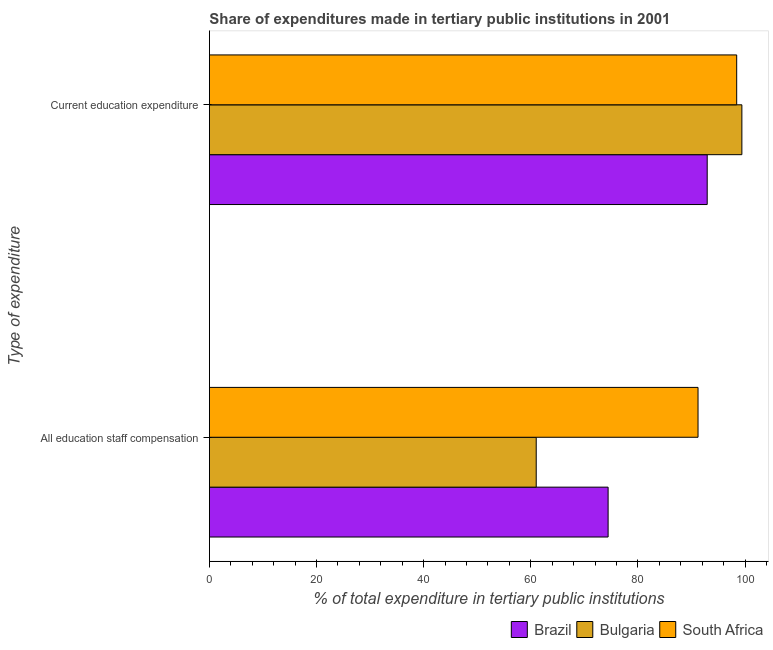How many different coloured bars are there?
Your answer should be compact. 3. Are the number of bars per tick equal to the number of legend labels?
Your answer should be compact. Yes. What is the label of the 1st group of bars from the top?
Ensure brevity in your answer.  Current education expenditure. What is the expenditure in staff compensation in South Africa?
Make the answer very short. 91.23. Across all countries, what is the maximum expenditure in staff compensation?
Your answer should be very brief. 91.23. Across all countries, what is the minimum expenditure in education?
Ensure brevity in your answer.  92.94. In which country was the expenditure in staff compensation maximum?
Give a very brief answer. South Africa. What is the total expenditure in education in the graph?
Your response must be concise. 290.8. What is the difference between the expenditure in staff compensation in South Africa and that in Bulgaria?
Give a very brief answer. 30.21. What is the difference between the expenditure in education in Bulgaria and the expenditure in staff compensation in South Africa?
Your answer should be compact. 8.18. What is the average expenditure in education per country?
Keep it short and to the point. 96.93. What is the difference between the expenditure in staff compensation and expenditure in education in Bulgaria?
Give a very brief answer. -38.4. In how many countries, is the expenditure in staff compensation greater than 16 %?
Give a very brief answer. 3. What is the ratio of the expenditure in education in Brazil to that in South Africa?
Your answer should be very brief. 0.94. Is the expenditure in education in Brazil less than that in South Africa?
Offer a very short reply. Yes. In how many countries, is the expenditure in education greater than the average expenditure in education taken over all countries?
Offer a terse response. 2. What does the 1st bar from the top in Current education expenditure represents?
Your response must be concise. South Africa. What does the 3rd bar from the bottom in All education staff compensation represents?
Offer a very short reply. South Africa. How many bars are there?
Ensure brevity in your answer.  6. Are all the bars in the graph horizontal?
Your answer should be compact. Yes. How many countries are there in the graph?
Provide a succinct answer. 3. Are the values on the major ticks of X-axis written in scientific E-notation?
Keep it short and to the point. No. Does the graph contain any zero values?
Offer a very short reply. No. What is the title of the graph?
Provide a succinct answer. Share of expenditures made in tertiary public institutions in 2001. Does "Montenegro" appear as one of the legend labels in the graph?
Provide a succinct answer. No. What is the label or title of the X-axis?
Ensure brevity in your answer.  % of total expenditure in tertiary public institutions. What is the label or title of the Y-axis?
Give a very brief answer. Type of expenditure. What is the % of total expenditure in tertiary public institutions of Brazil in All education staff compensation?
Give a very brief answer. 74.44. What is the % of total expenditure in tertiary public institutions in Bulgaria in All education staff compensation?
Ensure brevity in your answer.  61.02. What is the % of total expenditure in tertiary public institutions in South Africa in All education staff compensation?
Give a very brief answer. 91.23. What is the % of total expenditure in tertiary public institutions of Brazil in Current education expenditure?
Provide a short and direct response. 92.94. What is the % of total expenditure in tertiary public institutions in Bulgaria in Current education expenditure?
Make the answer very short. 99.41. What is the % of total expenditure in tertiary public institutions of South Africa in Current education expenditure?
Give a very brief answer. 98.45. Across all Type of expenditure, what is the maximum % of total expenditure in tertiary public institutions in Brazil?
Ensure brevity in your answer.  92.94. Across all Type of expenditure, what is the maximum % of total expenditure in tertiary public institutions in Bulgaria?
Provide a short and direct response. 99.41. Across all Type of expenditure, what is the maximum % of total expenditure in tertiary public institutions of South Africa?
Your response must be concise. 98.45. Across all Type of expenditure, what is the minimum % of total expenditure in tertiary public institutions of Brazil?
Provide a short and direct response. 74.44. Across all Type of expenditure, what is the minimum % of total expenditure in tertiary public institutions of Bulgaria?
Your answer should be very brief. 61.02. Across all Type of expenditure, what is the minimum % of total expenditure in tertiary public institutions in South Africa?
Provide a short and direct response. 91.23. What is the total % of total expenditure in tertiary public institutions in Brazil in the graph?
Keep it short and to the point. 167.38. What is the total % of total expenditure in tertiary public institutions in Bulgaria in the graph?
Provide a short and direct response. 160.43. What is the total % of total expenditure in tertiary public institutions of South Africa in the graph?
Ensure brevity in your answer.  189.68. What is the difference between the % of total expenditure in tertiary public institutions in Brazil in All education staff compensation and that in Current education expenditure?
Make the answer very short. -18.5. What is the difference between the % of total expenditure in tertiary public institutions of Bulgaria in All education staff compensation and that in Current education expenditure?
Provide a short and direct response. -38.4. What is the difference between the % of total expenditure in tertiary public institutions in South Africa in All education staff compensation and that in Current education expenditure?
Offer a terse response. -7.22. What is the difference between the % of total expenditure in tertiary public institutions of Brazil in All education staff compensation and the % of total expenditure in tertiary public institutions of Bulgaria in Current education expenditure?
Provide a short and direct response. -24.97. What is the difference between the % of total expenditure in tertiary public institutions of Brazil in All education staff compensation and the % of total expenditure in tertiary public institutions of South Africa in Current education expenditure?
Provide a short and direct response. -24.01. What is the difference between the % of total expenditure in tertiary public institutions of Bulgaria in All education staff compensation and the % of total expenditure in tertiary public institutions of South Africa in Current education expenditure?
Keep it short and to the point. -37.43. What is the average % of total expenditure in tertiary public institutions of Brazil per Type of expenditure?
Keep it short and to the point. 83.69. What is the average % of total expenditure in tertiary public institutions of Bulgaria per Type of expenditure?
Make the answer very short. 80.22. What is the average % of total expenditure in tertiary public institutions of South Africa per Type of expenditure?
Give a very brief answer. 94.84. What is the difference between the % of total expenditure in tertiary public institutions of Brazil and % of total expenditure in tertiary public institutions of Bulgaria in All education staff compensation?
Provide a short and direct response. 13.42. What is the difference between the % of total expenditure in tertiary public institutions in Brazil and % of total expenditure in tertiary public institutions in South Africa in All education staff compensation?
Make the answer very short. -16.79. What is the difference between the % of total expenditure in tertiary public institutions in Bulgaria and % of total expenditure in tertiary public institutions in South Africa in All education staff compensation?
Make the answer very short. -30.21. What is the difference between the % of total expenditure in tertiary public institutions of Brazil and % of total expenditure in tertiary public institutions of Bulgaria in Current education expenditure?
Keep it short and to the point. -6.47. What is the difference between the % of total expenditure in tertiary public institutions of Brazil and % of total expenditure in tertiary public institutions of South Africa in Current education expenditure?
Your answer should be very brief. -5.51. What is the difference between the % of total expenditure in tertiary public institutions of Bulgaria and % of total expenditure in tertiary public institutions of South Africa in Current education expenditure?
Your answer should be compact. 0.97. What is the ratio of the % of total expenditure in tertiary public institutions of Brazil in All education staff compensation to that in Current education expenditure?
Your response must be concise. 0.8. What is the ratio of the % of total expenditure in tertiary public institutions of Bulgaria in All education staff compensation to that in Current education expenditure?
Your answer should be very brief. 0.61. What is the ratio of the % of total expenditure in tertiary public institutions of South Africa in All education staff compensation to that in Current education expenditure?
Your answer should be very brief. 0.93. What is the difference between the highest and the second highest % of total expenditure in tertiary public institutions in Brazil?
Offer a very short reply. 18.5. What is the difference between the highest and the second highest % of total expenditure in tertiary public institutions in Bulgaria?
Keep it short and to the point. 38.4. What is the difference between the highest and the second highest % of total expenditure in tertiary public institutions of South Africa?
Your answer should be compact. 7.22. What is the difference between the highest and the lowest % of total expenditure in tertiary public institutions in Bulgaria?
Offer a very short reply. 38.4. What is the difference between the highest and the lowest % of total expenditure in tertiary public institutions of South Africa?
Your response must be concise. 7.22. 